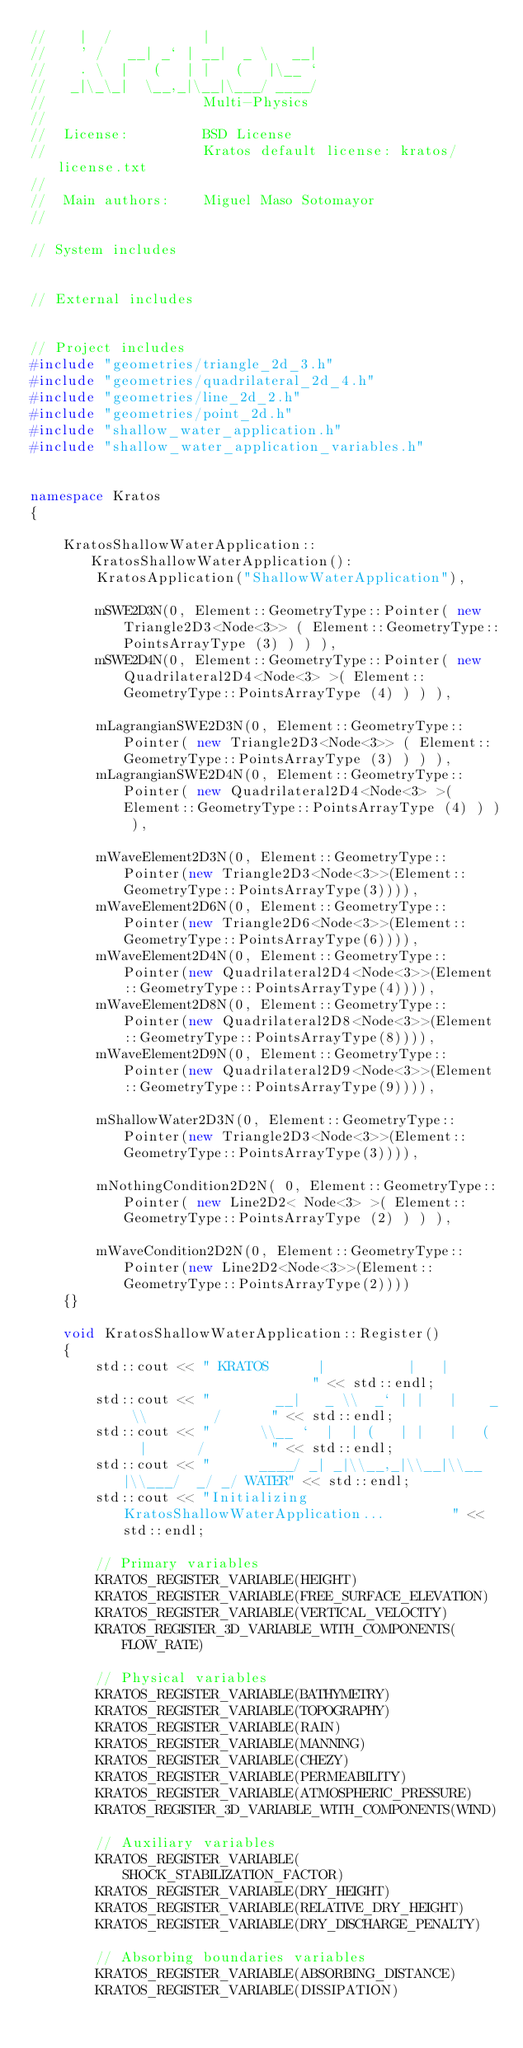Convert code to text. <code><loc_0><loc_0><loc_500><loc_500><_C++_>//    |  /           |
//    ' /   __| _` | __|  _ \   __|
//    . \  |   (   | |   (   |\__ `
//   _|\_\_|  \__,_|\__|\___/ ____/
//                   Multi-Physics
//
//  License:         BSD License
//                   Kratos default license: kratos/license.txt
//
//  Main authors:    Miguel Maso Sotomayor
//

// System includes


// External includes


// Project includes
#include "geometries/triangle_2d_3.h"
#include "geometries/quadrilateral_2d_4.h"
#include "geometries/line_2d_2.h"
#include "geometries/point_2d.h"
#include "shallow_water_application.h"
#include "shallow_water_application_variables.h"


namespace Kratos
{

    KratosShallowWaterApplication::KratosShallowWaterApplication():
        KratosApplication("ShallowWaterApplication"),

        mSWE2D3N(0, Element::GeometryType::Pointer( new Triangle2D3<Node<3>> ( Element::GeometryType::PointsArrayType (3) ) ) ),
        mSWE2D4N(0, Element::GeometryType::Pointer( new Quadrilateral2D4<Node<3> >( Element::GeometryType::PointsArrayType (4) ) ) ),

        mLagrangianSWE2D3N(0, Element::GeometryType::Pointer( new Triangle2D3<Node<3>> ( Element::GeometryType::PointsArrayType (3) ) ) ),
        mLagrangianSWE2D4N(0, Element::GeometryType::Pointer( new Quadrilateral2D4<Node<3> >( Element::GeometryType::PointsArrayType (4) ) ) ),

        mWaveElement2D3N(0, Element::GeometryType::Pointer(new Triangle2D3<Node<3>>(Element::GeometryType::PointsArrayType(3)))),
        mWaveElement2D6N(0, Element::GeometryType::Pointer(new Triangle2D6<Node<3>>(Element::GeometryType::PointsArrayType(6)))),
        mWaveElement2D4N(0, Element::GeometryType::Pointer(new Quadrilateral2D4<Node<3>>(Element::GeometryType::PointsArrayType(4)))),
        mWaveElement2D8N(0, Element::GeometryType::Pointer(new Quadrilateral2D8<Node<3>>(Element::GeometryType::PointsArrayType(8)))),
        mWaveElement2D9N(0, Element::GeometryType::Pointer(new Quadrilateral2D9<Node<3>>(Element::GeometryType::PointsArrayType(9)))),

        mShallowWater2D3N(0, Element::GeometryType::Pointer(new Triangle2D3<Node<3>>(Element::GeometryType::PointsArrayType(3)))),

        mNothingCondition2D2N( 0, Element::GeometryType::Pointer( new Line2D2< Node<3> >( Element::GeometryType::PointsArrayType (2) ) ) ),

        mWaveCondition2D2N(0, Element::GeometryType::Pointer(new Line2D2<Node<3>>(Element::GeometryType::PointsArrayType(2))))
    {}

    void KratosShallowWaterApplication::Register()
    {
        std::cout << " KRATOS      |          |   |                        " << std::endl;
        std::cout << "        __|   _ \\  _` | |   |    _ \\        /      " << std::endl;
        std::cout << "      \\__ `  |  | (   | |   |   (   |      /        " << std::endl;
        std::cout << "      ____/ _| _|\\__,_|\\__|\\__|\\___/  _/ _/ WATER" << std::endl;
        std::cout << "Initializing KratosShallowWaterApplication...        " << std::endl;

        // Primary variables
        KRATOS_REGISTER_VARIABLE(HEIGHT)
        KRATOS_REGISTER_VARIABLE(FREE_SURFACE_ELEVATION)
        KRATOS_REGISTER_VARIABLE(VERTICAL_VELOCITY)
        KRATOS_REGISTER_3D_VARIABLE_WITH_COMPONENTS(FLOW_RATE)

        // Physical variables
        KRATOS_REGISTER_VARIABLE(BATHYMETRY)
        KRATOS_REGISTER_VARIABLE(TOPOGRAPHY)
        KRATOS_REGISTER_VARIABLE(RAIN)
        KRATOS_REGISTER_VARIABLE(MANNING)
        KRATOS_REGISTER_VARIABLE(CHEZY)
        KRATOS_REGISTER_VARIABLE(PERMEABILITY)
        KRATOS_REGISTER_VARIABLE(ATMOSPHERIC_PRESSURE)
        KRATOS_REGISTER_3D_VARIABLE_WITH_COMPONENTS(WIND)

        // Auxiliary variables
        KRATOS_REGISTER_VARIABLE(SHOCK_STABILIZATION_FACTOR)
        KRATOS_REGISTER_VARIABLE(DRY_HEIGHT)
        KRATOS_REGISTER_VARIABLE(RELATIVE_DRY_HEIGHT)
        KRATOS_REGISTER_VARIABLE(DRY_DISCHARGE_PENALTY)

        // Absorbing boundaries variables
        KRATOS_REGISTER_VARIABLE(ABSORBING_DISTANCE)
        KRATOS_REGISTER_VARIABLE(DISSIPATION)</code> 